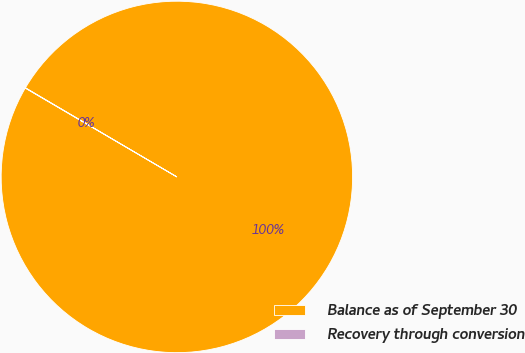<chart> <loc_0><loc_0><loc_500><loc_500><pie_chart><fcel>Balance as of September 30<fcel>Recovery through conversion<nl><fcel>99.97%<fcel>0.03%<nl></chart> 